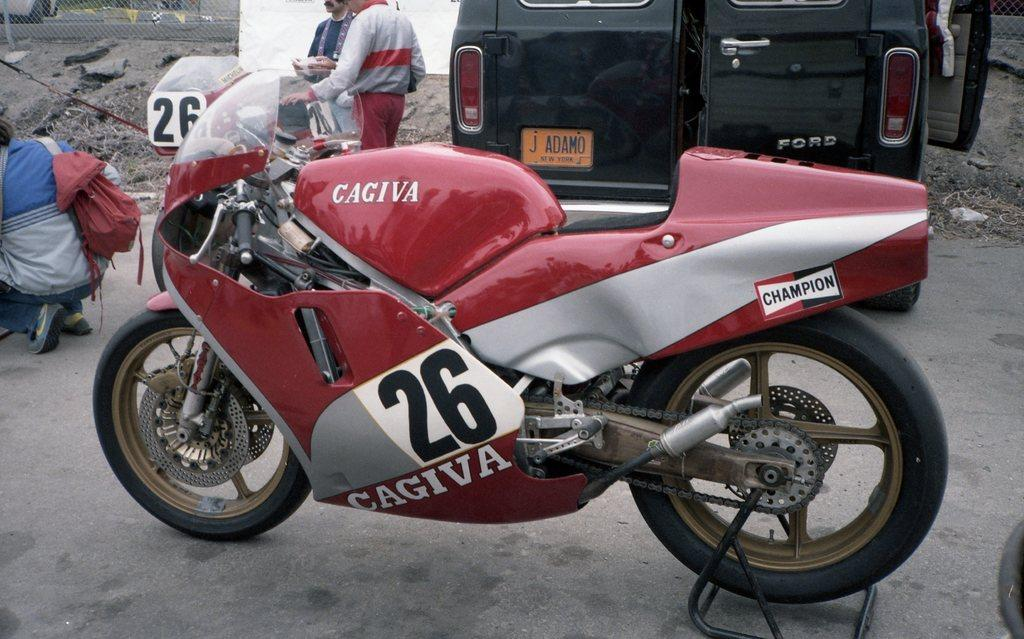What is the main subject of the image? The main subject of the image is a motorbike. Can you describe the motorbike's position in the image? The motorbike is on the ground in the image. What color is the motorbike? The motorbike is red in color. How many wheels does the motorbike have? The motorbike has two wheels. Are there any people near the motorbike? Yes, there are people standing near the motorbike. Where is the motorbike located? The motorbike is on a road in the image. What type of trousers are the people wearing while adjusting the motorbike's transport in the image? There is no indication in the image that the people are wearing trousers or adjusting the motorbike's transport. 